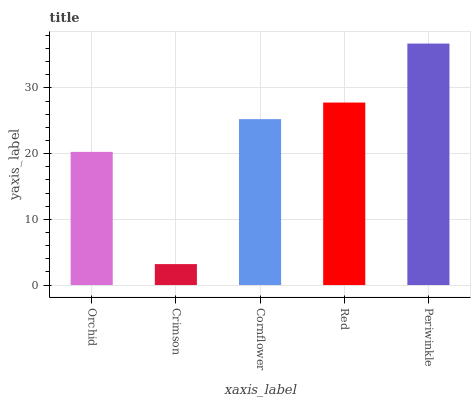Is Crimson the minimum?
Answer yes or no. Yes. Is Periwinkle the maximum?
Answer yes or no. Yes. Is Cornflower the minimum?
Answer yes or no. No. Is Cornflower the maximum?
Answer yes or no. No. Is Cornflower greater than Crimson?
Answer yes or no. Yes. Is Crimson less than Cornflower?
Answer yes or no. Yes. Is Crimson greater than Cornflower?
Answer yes or no. No. Is Cornflower less than Crimson?
Answer yes or no. No. Is Cornflower the high median?
Answer yes or no. Yes. Is Cornflower the low median?
Answer yes or no. Yes. Is Red the high median?
Answer yes or no. No. Is Periwinkle the low median?
Answer yes or no. No. 